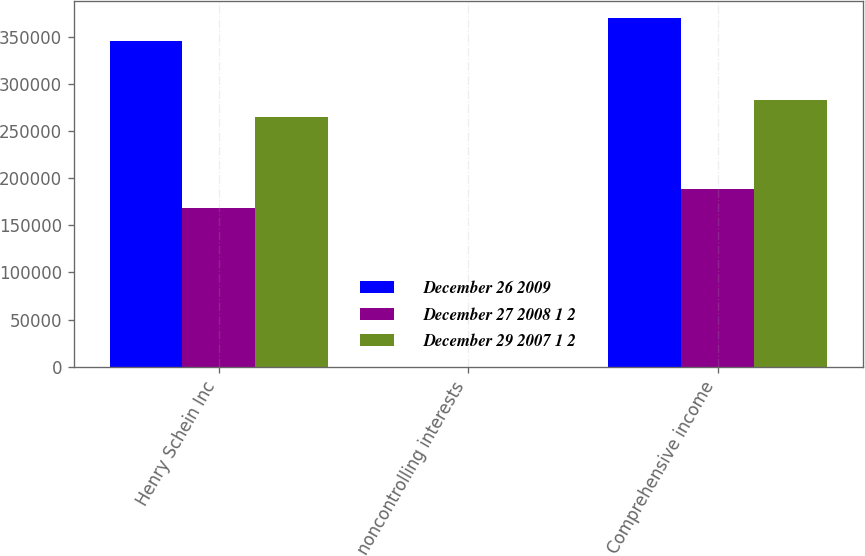<chart> <loc_0><loc_0><loc_500><loc_500><stacked_bar_chart><ecel><fcel>Henry Schein Inc<fcel>noncontrolling interests<fcel>Comprehensive income<nl><fcel>December 26 2009<fcel>345626<fcel>29<fcel>370171<nl><fcel>December 27 2008 1 2<fcel>168910<fcel>12<fcel>188767<nl><fcel>December 29 2007 1 2<fcel>264639<fcel>92<fcel>282935<nl></chart> 